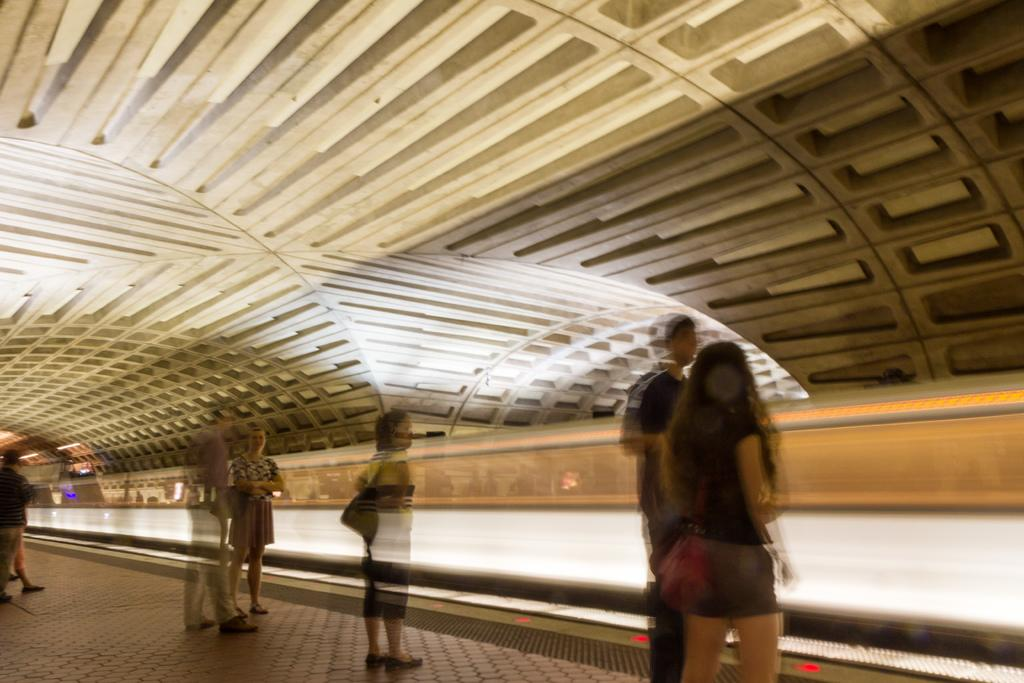What is happening in the image? There are people standing in the image. Where are the people standing? The people are standing on the floor. What is visible above the people in the image? There is a ceiling visible at the top of the image. What invention can be seen in the hands of the people in the image? There is no invention visible in the hands of the people in the image. What type of fowl is present in the image? There is no fowl present in the image. 